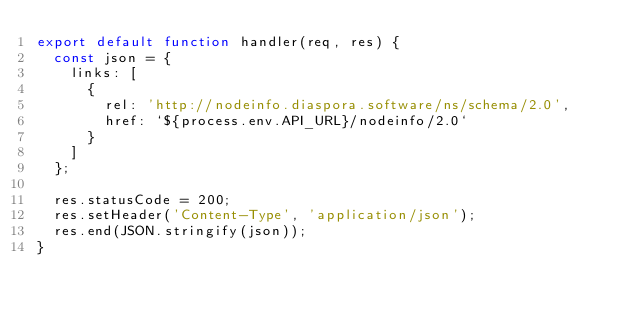Convert code to text. <code><loc_0><loc_0><loc_500><loc_500><_JavaScript_>export default function handler(req, res) {
	const json = {
		links: [
			{
				rel: 'http://nodeinfo.diaspora.software/ns/schema/2.0',
				href: `${process.env.API_URL}/nodeinfo/2.0`
			}
		]
	};

	res.statusCode = 200;
	res.setHeader('Content-Type', 'application/json');
	res.end(JSON.stringify(json));
} </code> 